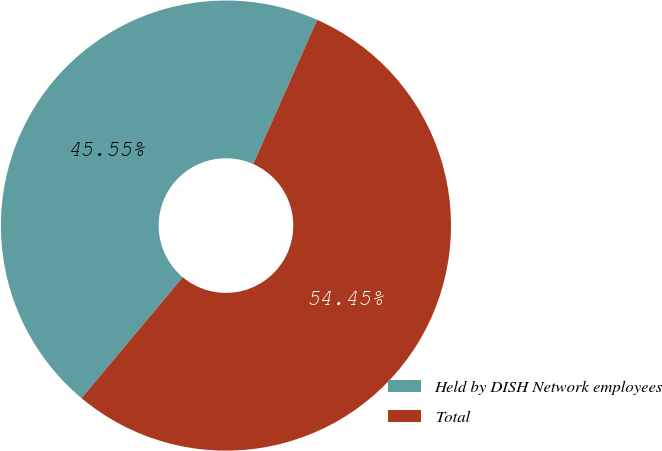<chart> <loc_0><loc_0><loc_500><loc_500><pie_chart><fcel>Held by DISH Network employees<fcel>Total<nl><fcel>45.55%<fcel>54.45%<nl></chart> 